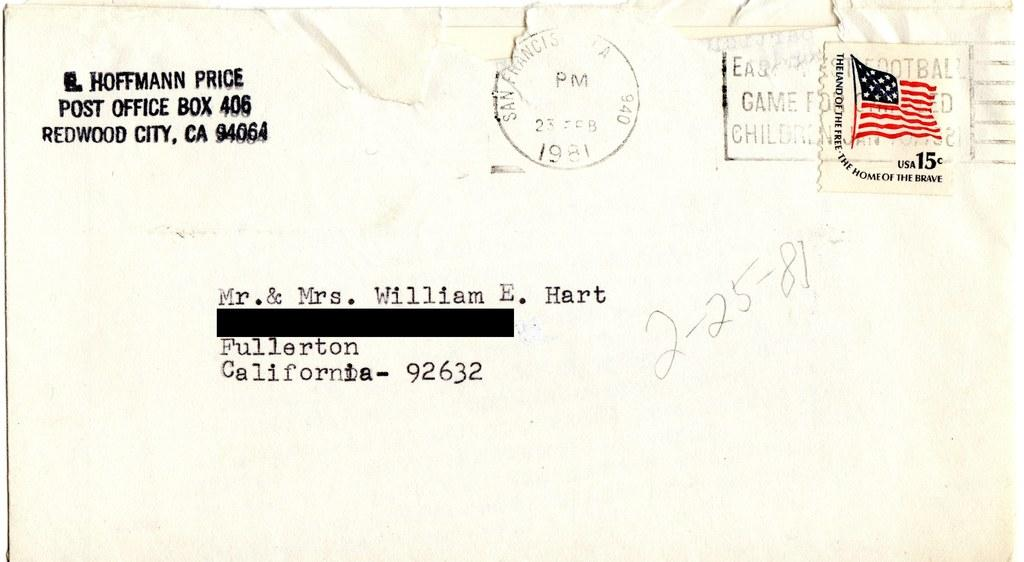<image>
Present a compact description of the photo's key features. A letter addressed to a home in Fullerton, California 